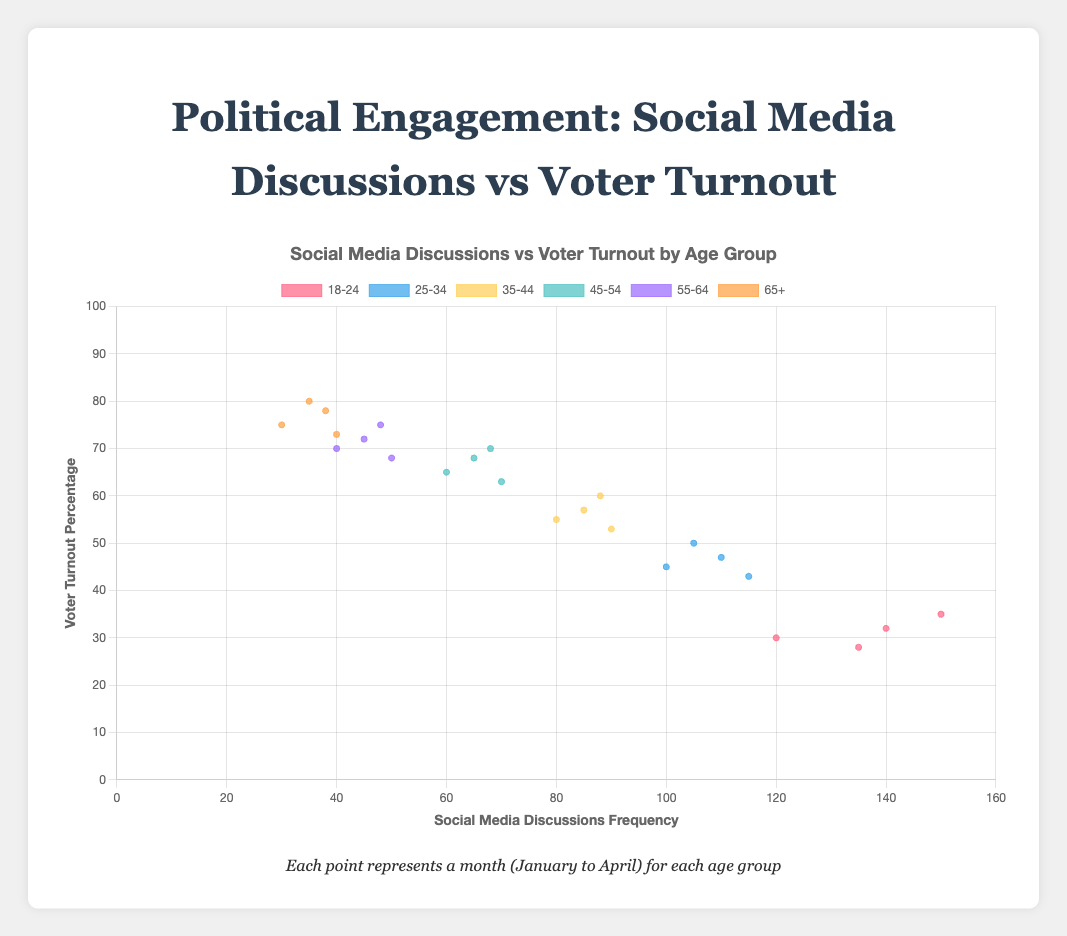What's the title of the chart? The chart's title can be found at the top of the figure. It provides an overview of what the chart represents.
Answer: Political Engagement: Social Media Discussions vs Voter Turnout Which age group has the highest voter turnout in April? Look at the "April" data point on the y-axis for each age group and identify the one with the highest percentage. The age group "65+" has the highest voter turnout in April.
Answer: 65+ How does social media discussion frequency vary for the 18-24 age group from January to April? Follow the social media discussions for the 18-24 age group across all months. The frequencies are 120 in January, 140 in February, 135 in March, and 150 in April.
Answer: 120, 140, 135, 150 Compare voter turnout rates in February between the 25-34 and 45-54 age groups. Which is higher? Look at the y-axis values for February for both age groups. The 45-54 age group has a voter turnout of 68%, while the 25-34 age group has 47%.
Answer: 45-54 Which age group exhibited the lowest social media discussion frequency overall? Compare the social media discussion frequencies across all age groups. The "65+" age group has discussions frequencies ranging from 30 to 40, which is the lowest.
Answer: 65+ What is the average voter turnout percentage for the 35-44 age group across all months? Sum the voter turnout percentages for January, February, March, and April, then divide by 4 (55+57+53+60)/4 = 56.25.
Answer: 56.25 Identify the age group with the greatest difference in social media discussions between January and April. Calculate the difference between January and April for each age group: 18-24 (150-120=30), 25-34 (105-100=5), 35-44 (88-80=8), 45-54 (68-60=8), 55-64 (48-40=8), 65+ (38-30=8). The 18-24 age group has the greatest difference.
Answer: 18-24 Is there a direct correlation between higher social media discussions and higher voter turnout for any age group? Look for patterns where an increase in social media discussions corresponds with an increase in voter turnout within the same age group. The age group 18-24 shows a notable trend where both metrics rise together but not strongly for other age groups.
Answer: 18-24 In which month did the 55-64 age group have the highest frequency of social media discussions? Check the social media discussion frequency data for the 55-64 age group across all months. It's highest in March with a frequency of 50.
Answer: March What is the trend in voter turnout for the 45-54 age group from January to April? Trace the voter turnout percentages for the 45-54 age group month by month: 65% in January, 68% in February, 63% in March, and 70% in April. This shows a generally increasing trend except for a dip in March.
Answer: Increasing with a dip in March 